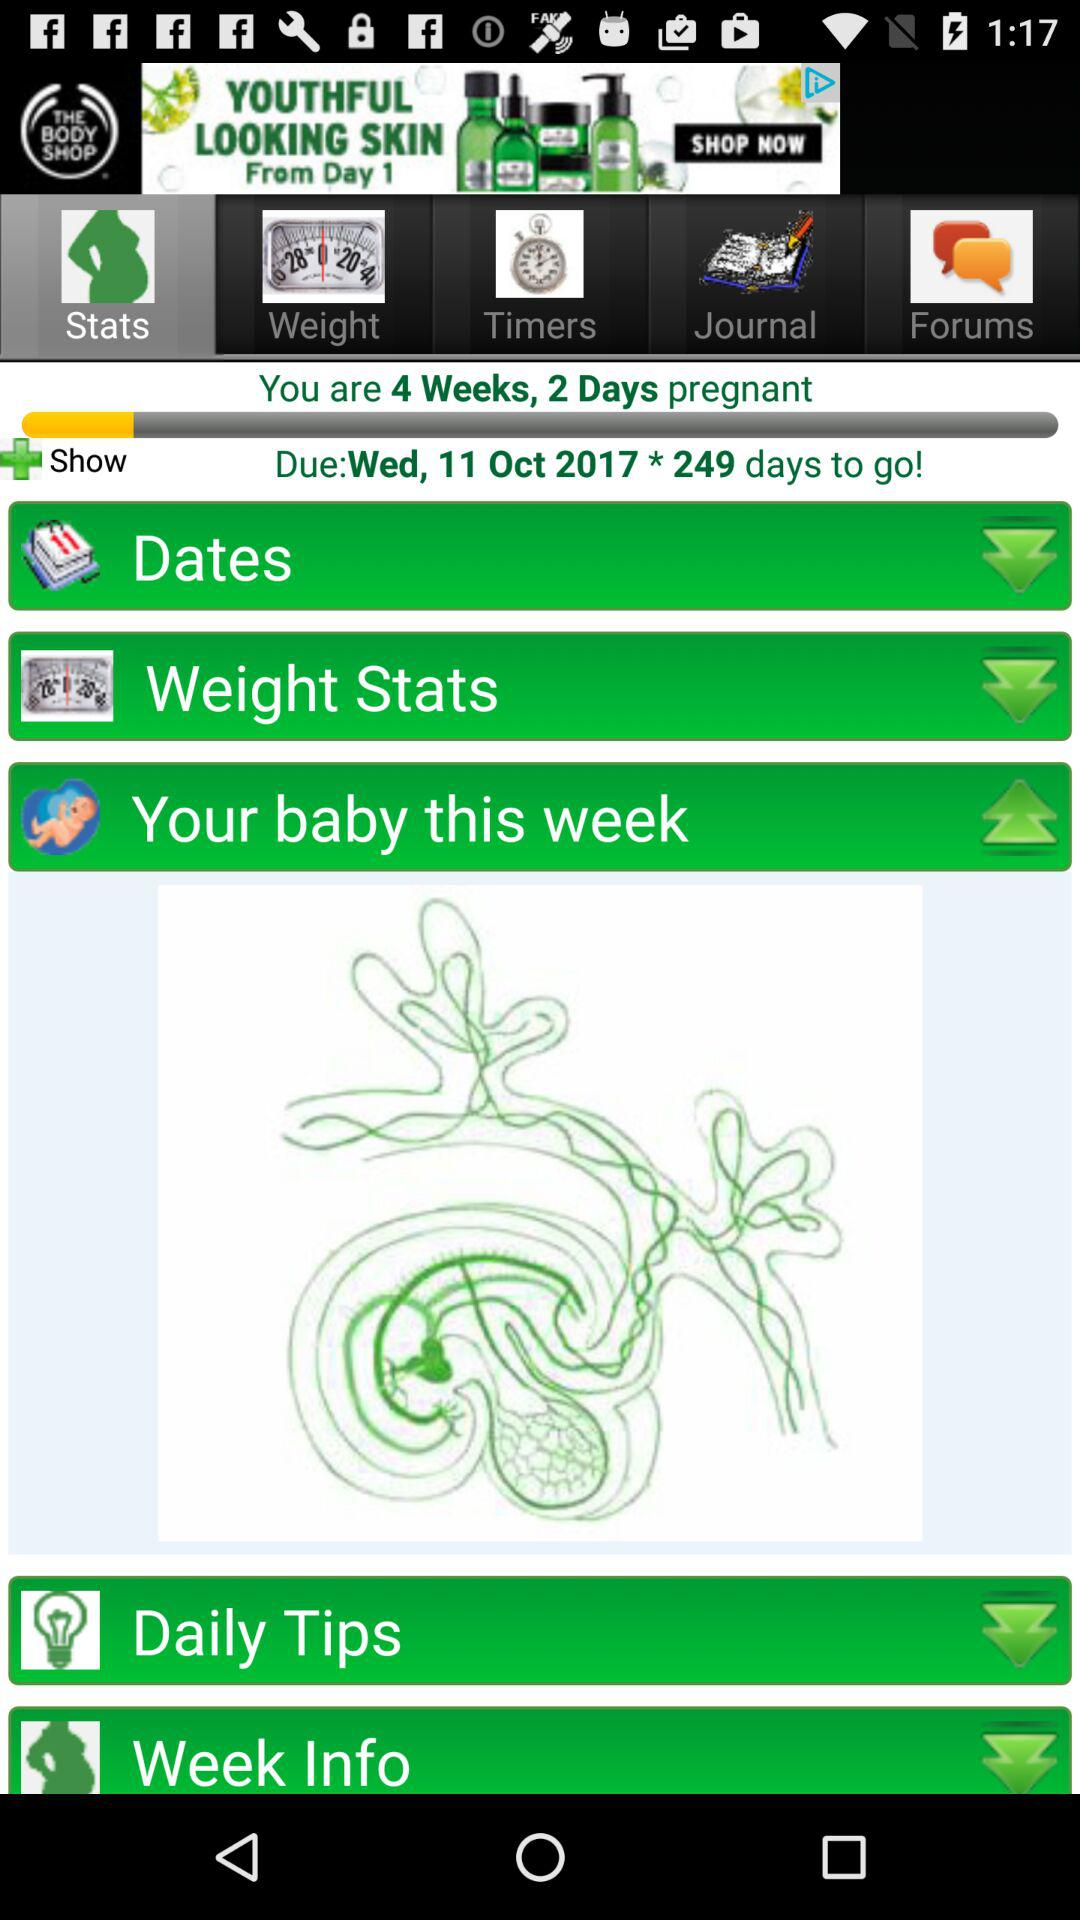What is the day on October 11? The day is Wednesday. 